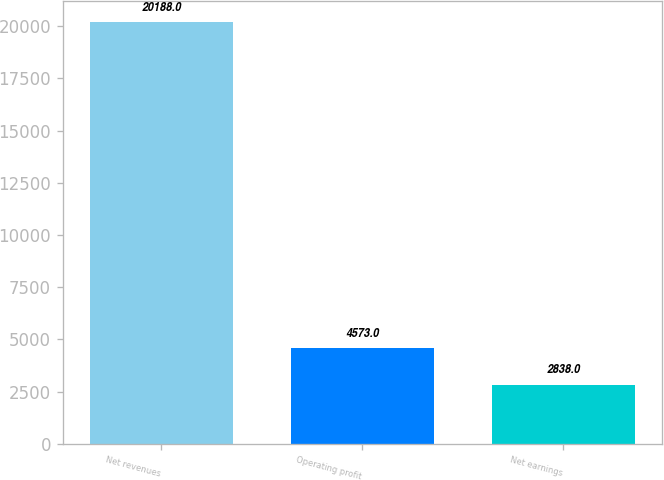Convert chart. <chart><loc_0><loc_0><loc_500><loc_500><bar_chart><fcel>Net revenues<fcel>Operating profit<fcel>Net earnings<nl><fcel>20188<fcel>4573<fcel>2838<nl></chart> 